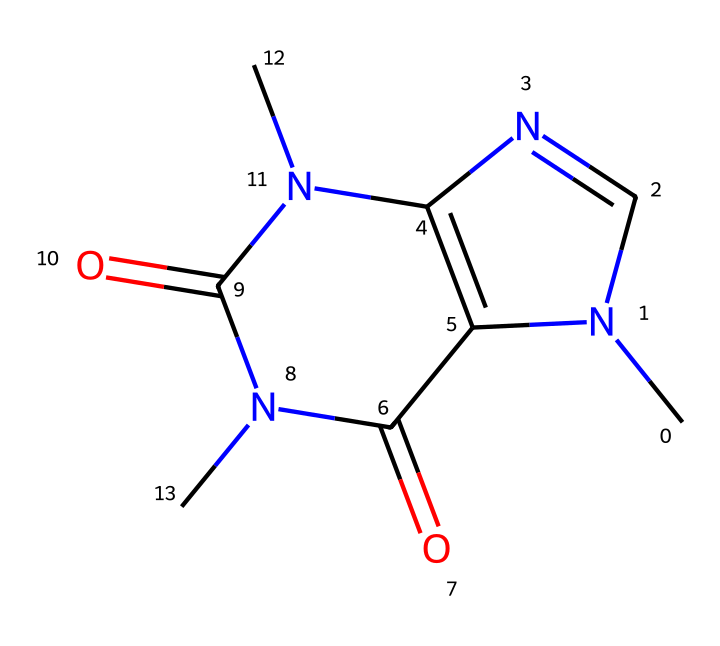What is the molecular formula of caffeine? To determine the molecular formula from the SMILES representation, count the number of each type of atom. The SMILES indicates there are 8 carbons (C), 10 hydrogens (H), 4 nitrogens (N), and 2 oxygens (O). Therefore, the molecular formula is C8H10N4O2.
Answer: C8H10N4O2 How many nitrogen atoms are present in caffeine? The SMILES shows that there are four distinct nitrogen atoms in the structure as indicated by the "N" characters. This count is straightforward as it directly corresponds to the number of nitrogen atoms represented.
Answer: 4 Is caffeine a type of alkaloid? Caffeine is a nitrogen-containing compound that is commonly classified as an alkaloid due to its structure and physiological effects, primarily affecting the central nervous system. This classification is based on the presence of nitrogen atoms in a heterocyclic ring.
Answer: Yes What is the function of the carbonyl groups in caffeine? The carbonyl groups (C=O) in caffeine serve as sites for potential hydrogen bonding and influence the compound's reactivity, solubility, and interactions with other biological molecules, thus playing a critical role in its pharmacological activity.
Answer: Reactivity How many rings are present in the structure of caffeine? By analyzing the SMILES representation, it can be seen that there are two fused rings present in the structure, which are characteristic features of the xanthine class of compounds, to which caffeine belongs.
Answer: 2 What type of bonding is primarily found in the rings of caffeine? The rings of caffeine consist mainly of aromatic bonding characterized by alternating single and double bonds, which contributes to the stability and unique properties of the compound.
Answer: Aromatic How does the presence of nitrogen atoms affect the behavior of caffeine? The nitrogen atoms in caffeine contribute to its basicity and are responsible for the compound's ability to act as a stimulant by affecting adenosine receptors in the brain, thus influencing neurotransmission and energy levels.
Answer: Stimulant 